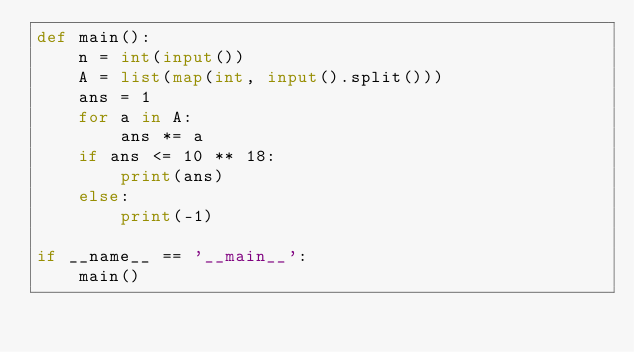Convert code to text. <code><loc_0><loc_0><loc_500><loc_500><_Python_>def main():
    n = int(input())
    A = list(map(int, input().split()))
    ans = 1
    for a in A:
        ans *= a
    if ans <= 10 ** 18:
        print(ans)
    else:
        print(-1)

if __name__ == '__main__':
    main()
</code> 